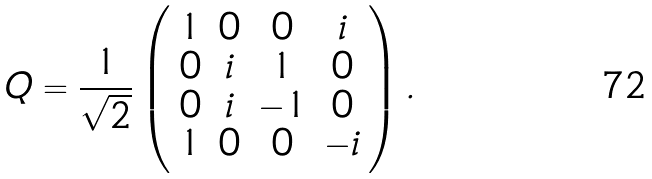Convert formula to latex. <formula><loc_0><loc_0><loc_500><loc_500>Q = \frac { 1 } { \sqrt { 2 } } \left ( \begin{array} { c c c c } 1 & 0 & 0 & i \\ 0 & i & 1 & 0 \\ 0 & i & - 1 & 0 \\ 1 & 0 & 0 & - i \end{array} \right ) .</formula> 